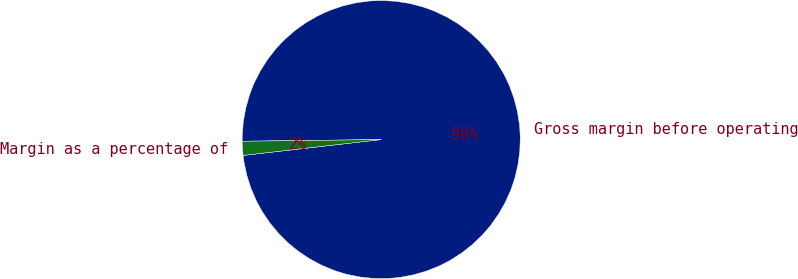Convert chart. <chart><loc_0><loc_0><loc_500><loc_500><pie_chart><fcel>Gross margin before operating<fcel>Margin as a percentage of<nl><fcel>98.37%<fcel>1.63%<nl></chart> 